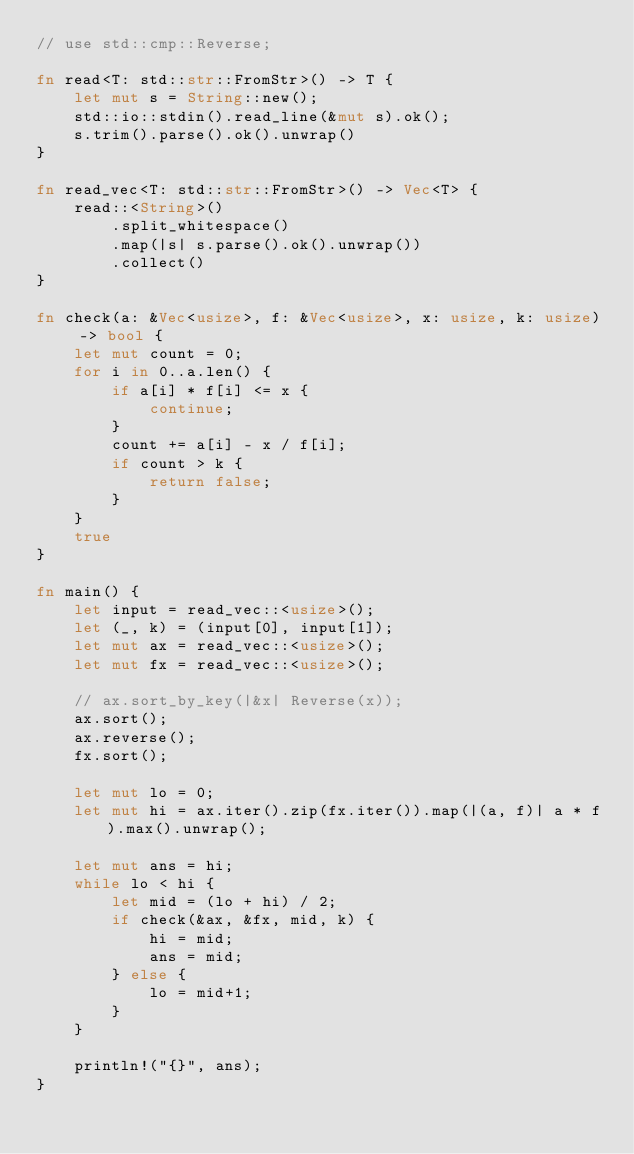Convert code to text. <code><loc_0><loc_0><loc_500><loc_500><_Rust_>// use std::cmp::Reverse;

fn read<T: std::str::FromStr>() -> T {
    let mut s = String::new();
    std::io::stdin().read_line(&mut s).ok();
    s.trim().parse().ok().unwrap()
}

fn read_vec<T: std::str::FromStr>() -> Vec<T> {
    read::<String>()
        .split_whitespace()
        .map(|s| s.parse().ok().unwrap())
        .collect()
}

fn check(a: &Vec<usize>, f: &Vec<usize>, x: usize, k: usize) -> bool {
    let mut count = 0;
    for i in 0..a.len() {
        if a[i] * f[i] <= x {
            continue;
        }
        count += a[i] - x / f[i];
        if count > k {
            return false;
        }
    }
    true
}

fn main() {
    let input = read_vec::<usize>();
    let (_, k) = (input[0], input[1]);
    let mut ax = read_vec::<usize>();
    let mut fx = read_vec::<usize>();

    // ax.sort_by_key(|&x| Reverse(x));
    ax.sort();
    ax.reverse();
    fx.sort();

    let mut lo = 0;
    let mut hi = ax.iter().zip(fx.iter()).map(|(a, f)| a * f).max().unwrap();

    let mut ans = hi;
    while lo < hi {
        let mid = (lo + hi) / 2;
        if check(&ax, &fx, mid, k) {
            hi = mid;
            ans = mid;
        } else {
            lo = mid+1;
        }
    }

    println!("{}", ans);
}</code> 